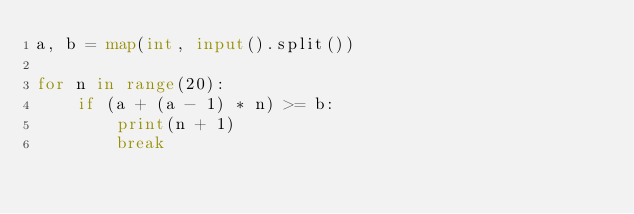Convert code to text. <code><loc_0><loc_0><loc_500><loc_500><_Python_>a, b = map(int, input().split())

for n in range(20):
    if (a + (a - 1) * n) >= b:
        print(n + 1)
        break</code> 